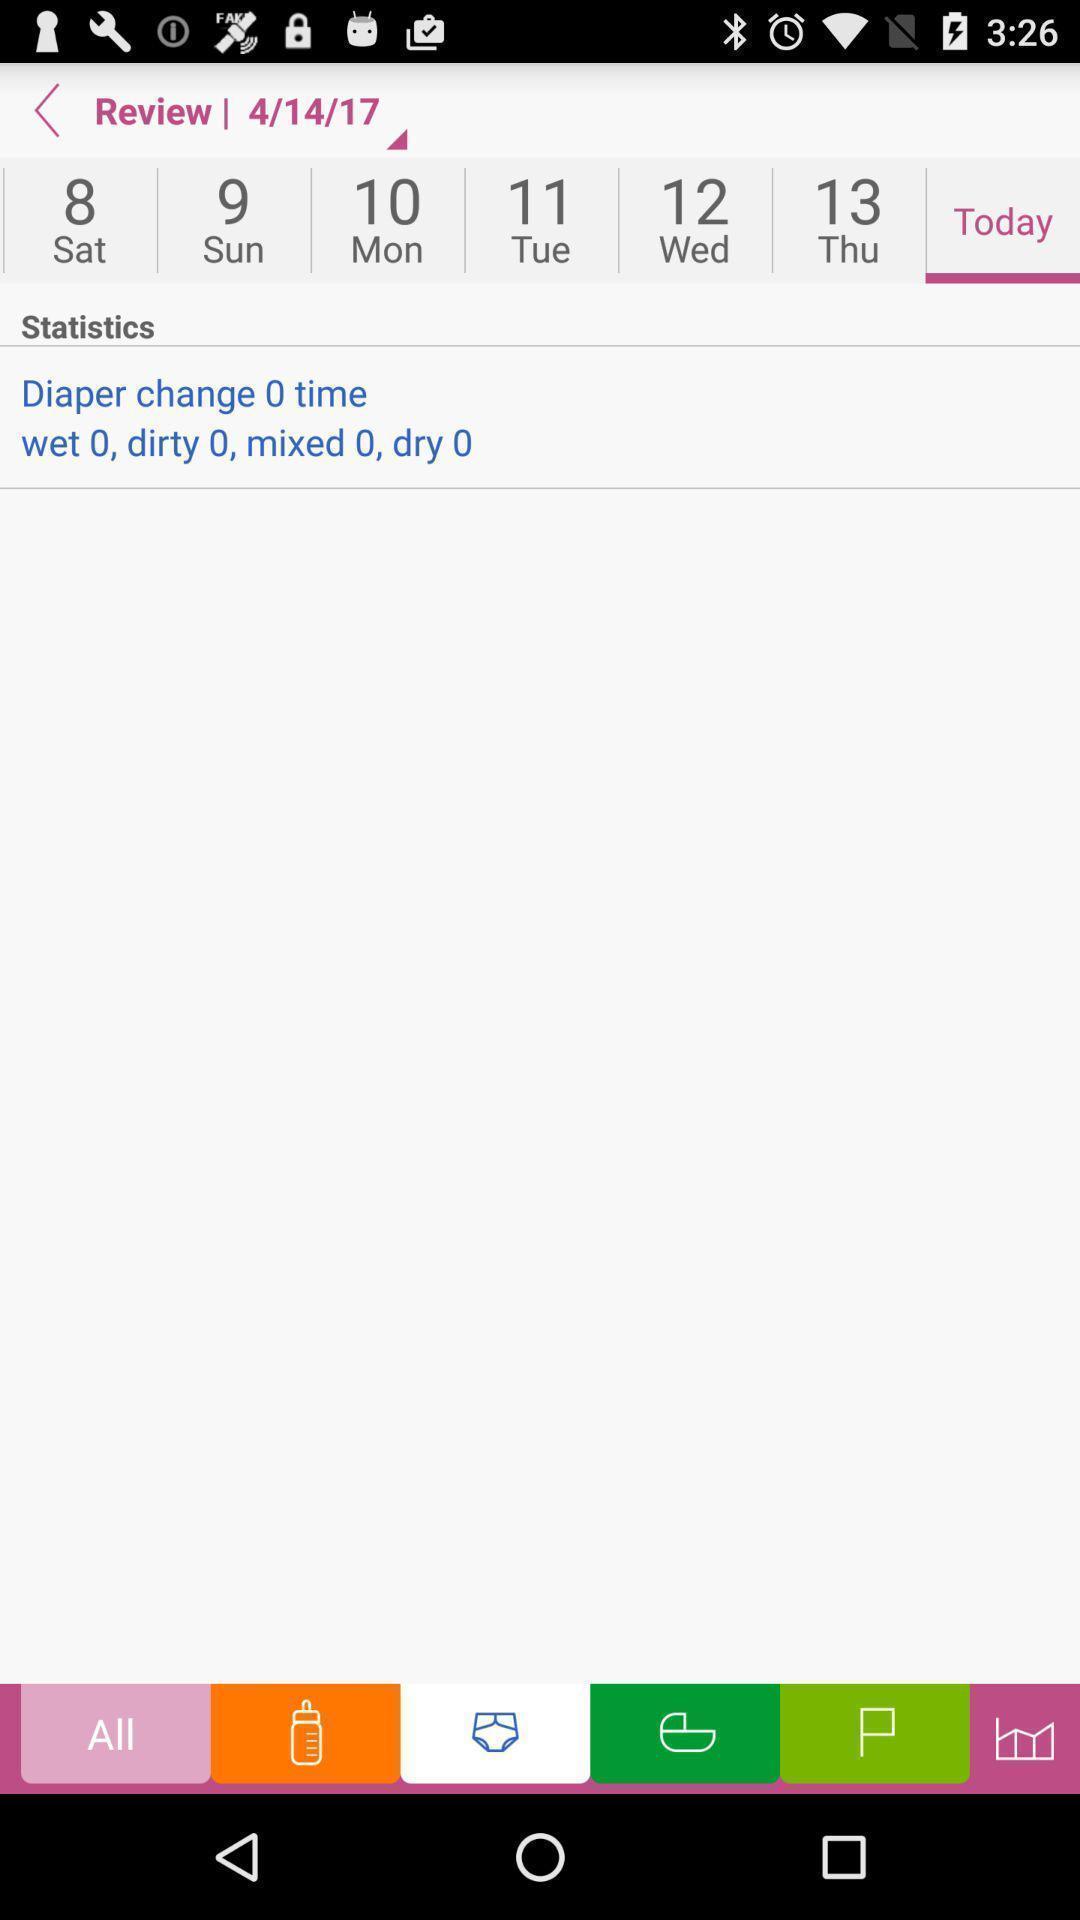What can you discern from this picture? Review page displaying in application. 